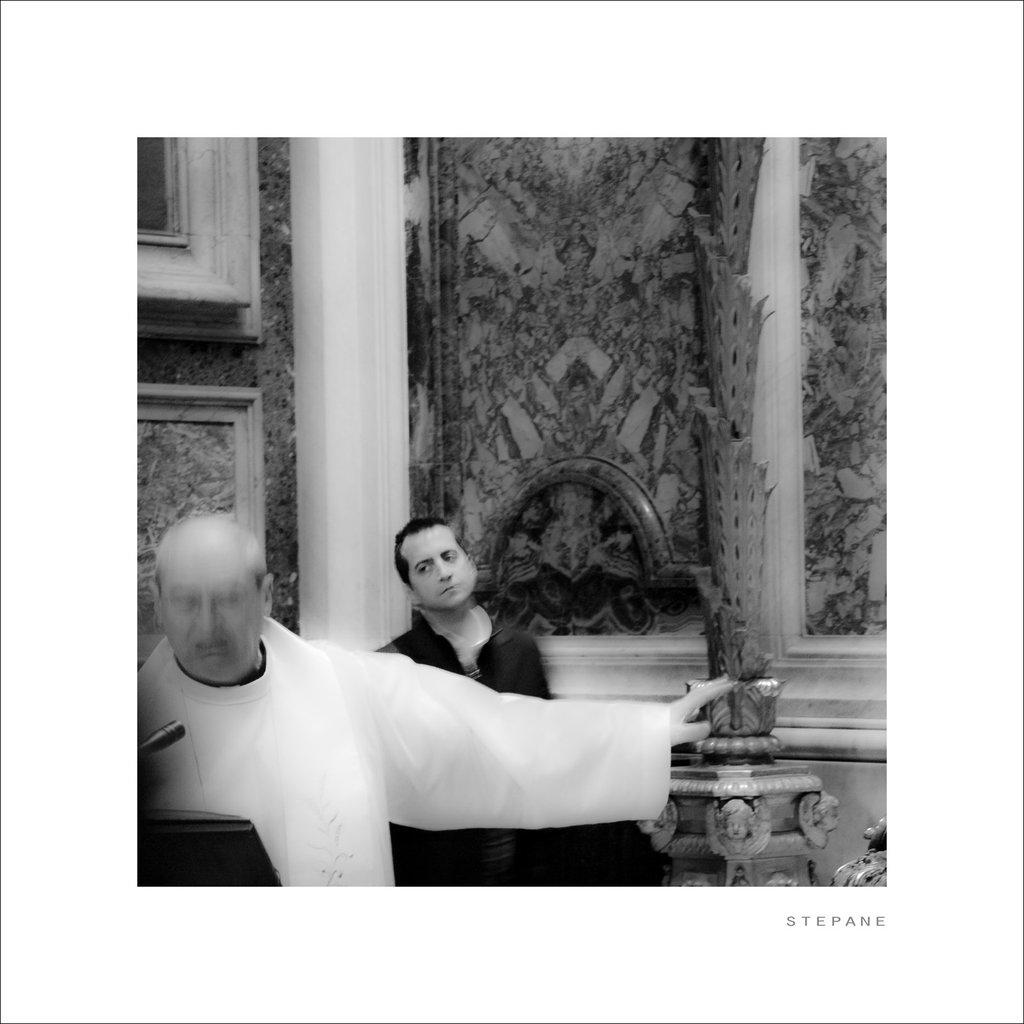How many people are present in the building in the image? There are two persons in the building. What object is on the podium in the image? There is a microphone on a podium. Can you describe any decorative elements in the image? There is a flower pot in the image. What is attached to the wall in the image? There are frames attached to the wall. What type of offer is being made by the person holding the knife in the image? There is no person holding a knife in the image. 